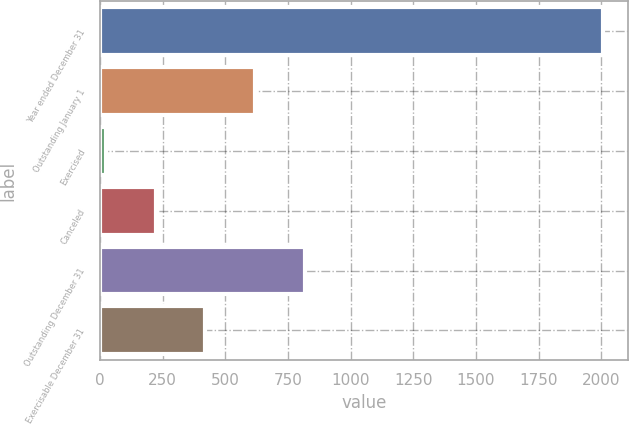Convert chart. <chart><loc_0><loc_0><loc_500><loc_500><bar_chart><fcel>Year ended December 31<fcel>Outstanding January 1<fcel>Exercised<fcel>Canceled<fcel>Outstanding December 31<fcel>Exercisable December 31<nl><fcel>2005<fcel>618.37<fcel>24.1<fcel>222.19<fcel>816.46<fcel>420.28<nl></chart> 